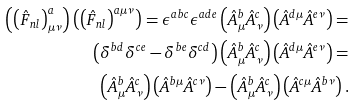Convert formula to latex. <formula><loc_0><loc_0><loc_500><loc_500>\left ( \left ( \hat { F } _ { n l } \right ) ^ { a } _ { \mu \nu } \right ) \left ( \left ( \hat { F } _ { n l } \right ) ^ { a \mu \nu } \right ) = \epsilon ^ { a b c } \epsilon ^ { a d e } \left ( \hat { A } ^ { b } _ { \mu } \hat { A } ^ { c } _ { \nu } \right ) \left ( \hat { A } ^ { d \mu } \hat { A } ^ { e \nu } \right ) = & \\ \left ( \delta ^ { b d } \delta ^ { c e } - \delta ^ { b e } \delta ^ { c d } \right ) \left ( \hat { A } ^ { b } _ { \mu } \hat { A } ^ { c } _ { \nu } \right ) \left ( \hat { A } ^ { d \mu } \hat { A } ^ { e \nu } \right ) = & \\ \left ( \hat { A } ^ { b } _ { \mu } \hat { A } ^ { c } _ { \nu } \right ) \left ( \hat { A } ^ { b \mu } \hat { A } ^ { c \nu } \right ) - \left ( \hat { A } ^ { b } _ { \mu } \hat { A } ^ { c } _ { \nu } \right ) \left ( \hat { A } ^ { c \mu } \hat { A } ^ { b \nu } \right ) .</formula> 